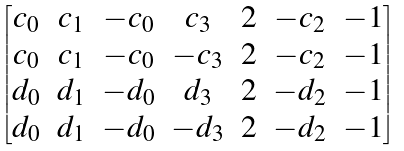<formula> <loc_0><loc_0><loc_500><loc_500>\begin{bmatrix} c _ { 0 } & c _ { 1 } & - c _ { 0 } & c _ { 3 } & 2 & - c _ { 2 } & - 1 \\ c _ { 0 } & c _ { 1 } & - c _ { 0 } & - c _ { 3 } & 2 & - c _ { 2 } & - 1 \\ d _ { 0 } & d _ { 1 } & - d _ { 0 } & d _ { 3 } & 2 & - d _ { 2 } & - 1 \\ d _ { 0 } & d _ { 1 } & - d _ { 0 } & - d _ { 3 } & 2 & - d _ { 2 } & - 1 \end{bmatrix}</formula> 